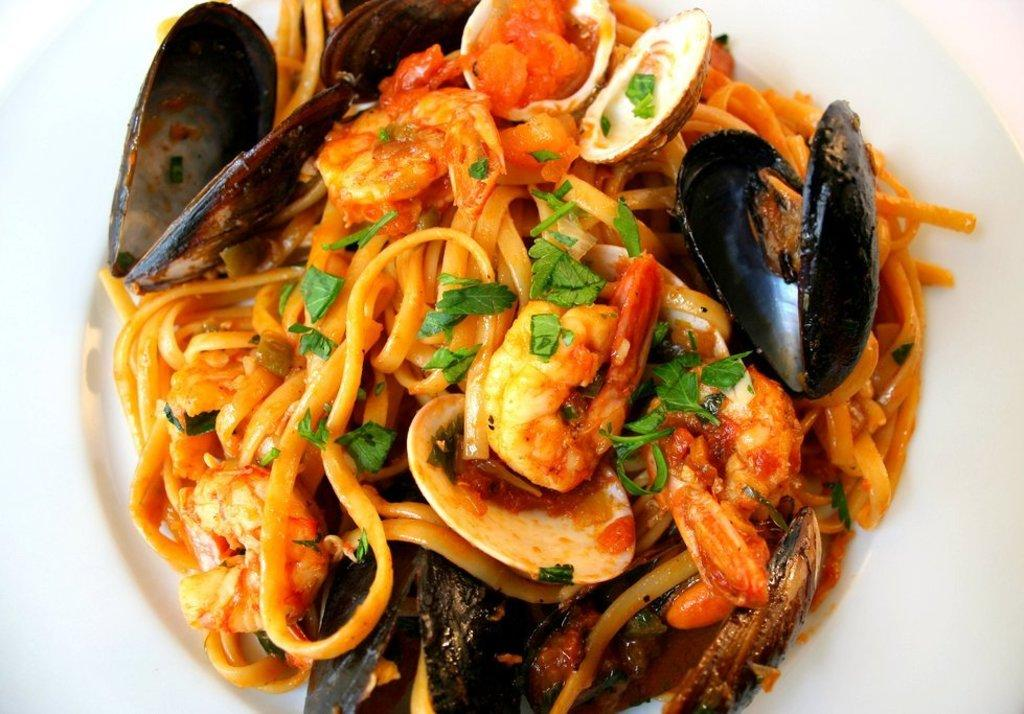What is located in the center of the image? There is a plate in the center of the image. What is on the plate? There is food on the plate. How many cushions are on the plate in the image? There are no cushions present on the plate in the image. 